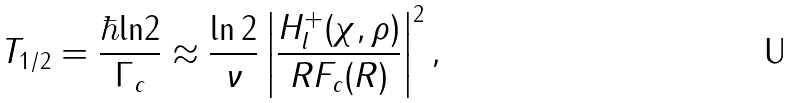Convert formula to latex. <formula><loc_0><loc_0><loc_500><loc_500>T _ { 1 / 2 } = \frac { \hbar { \ln } 2 } { \Gamma _ { c } } \approx \frac { \ln 2 } { \nu } \left | \frac { H _ { l } ^ { + } ( \chi , \rho ) } { R F _ { c } ( R ) } \right | ^ { 2 } ,</formula> 